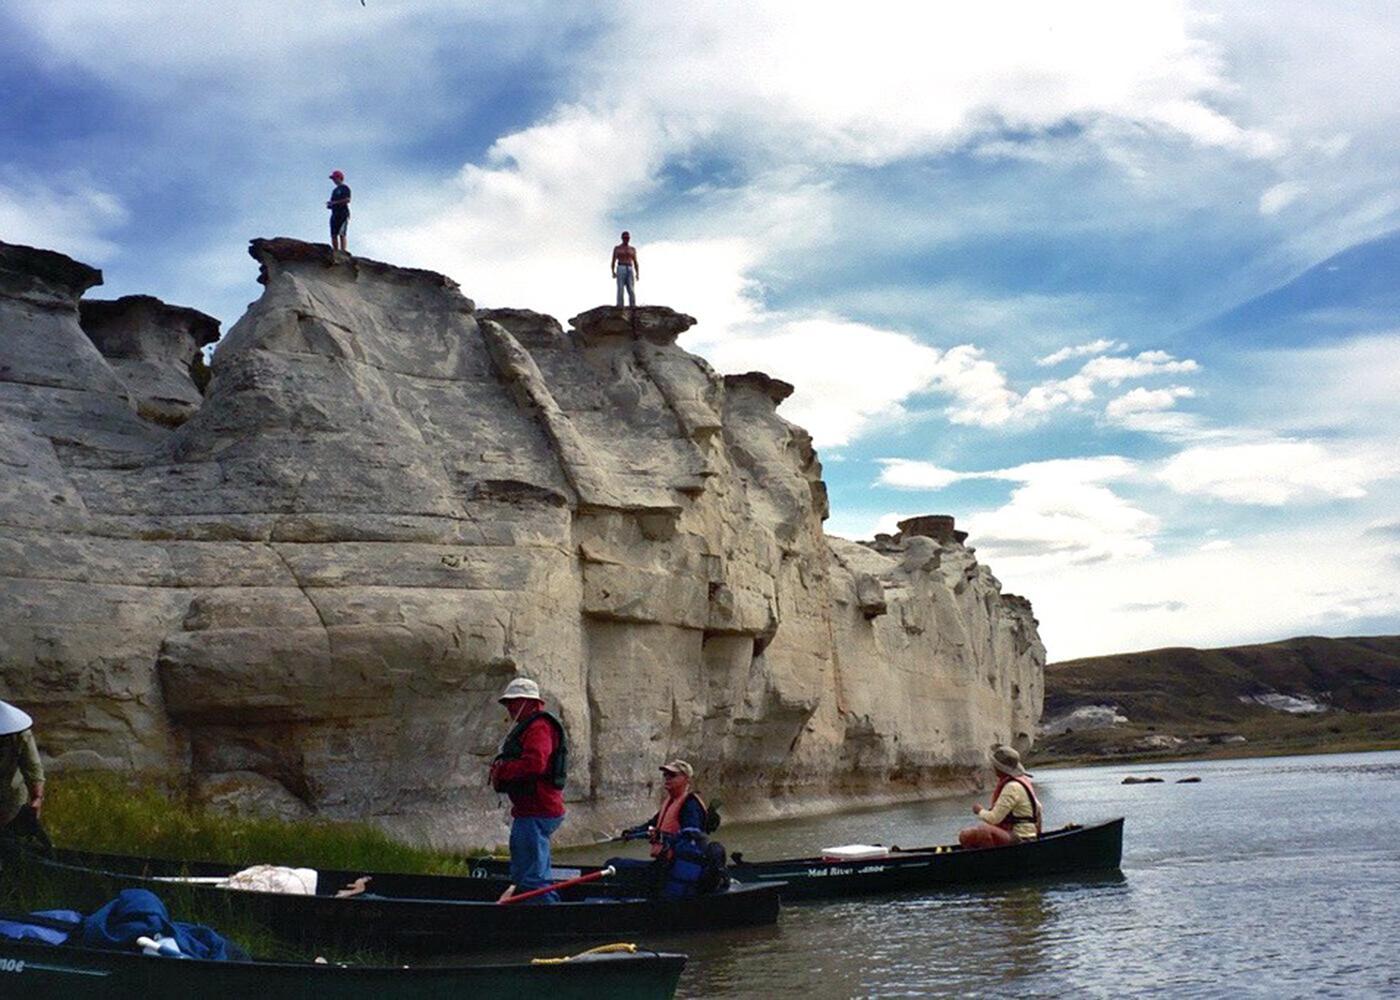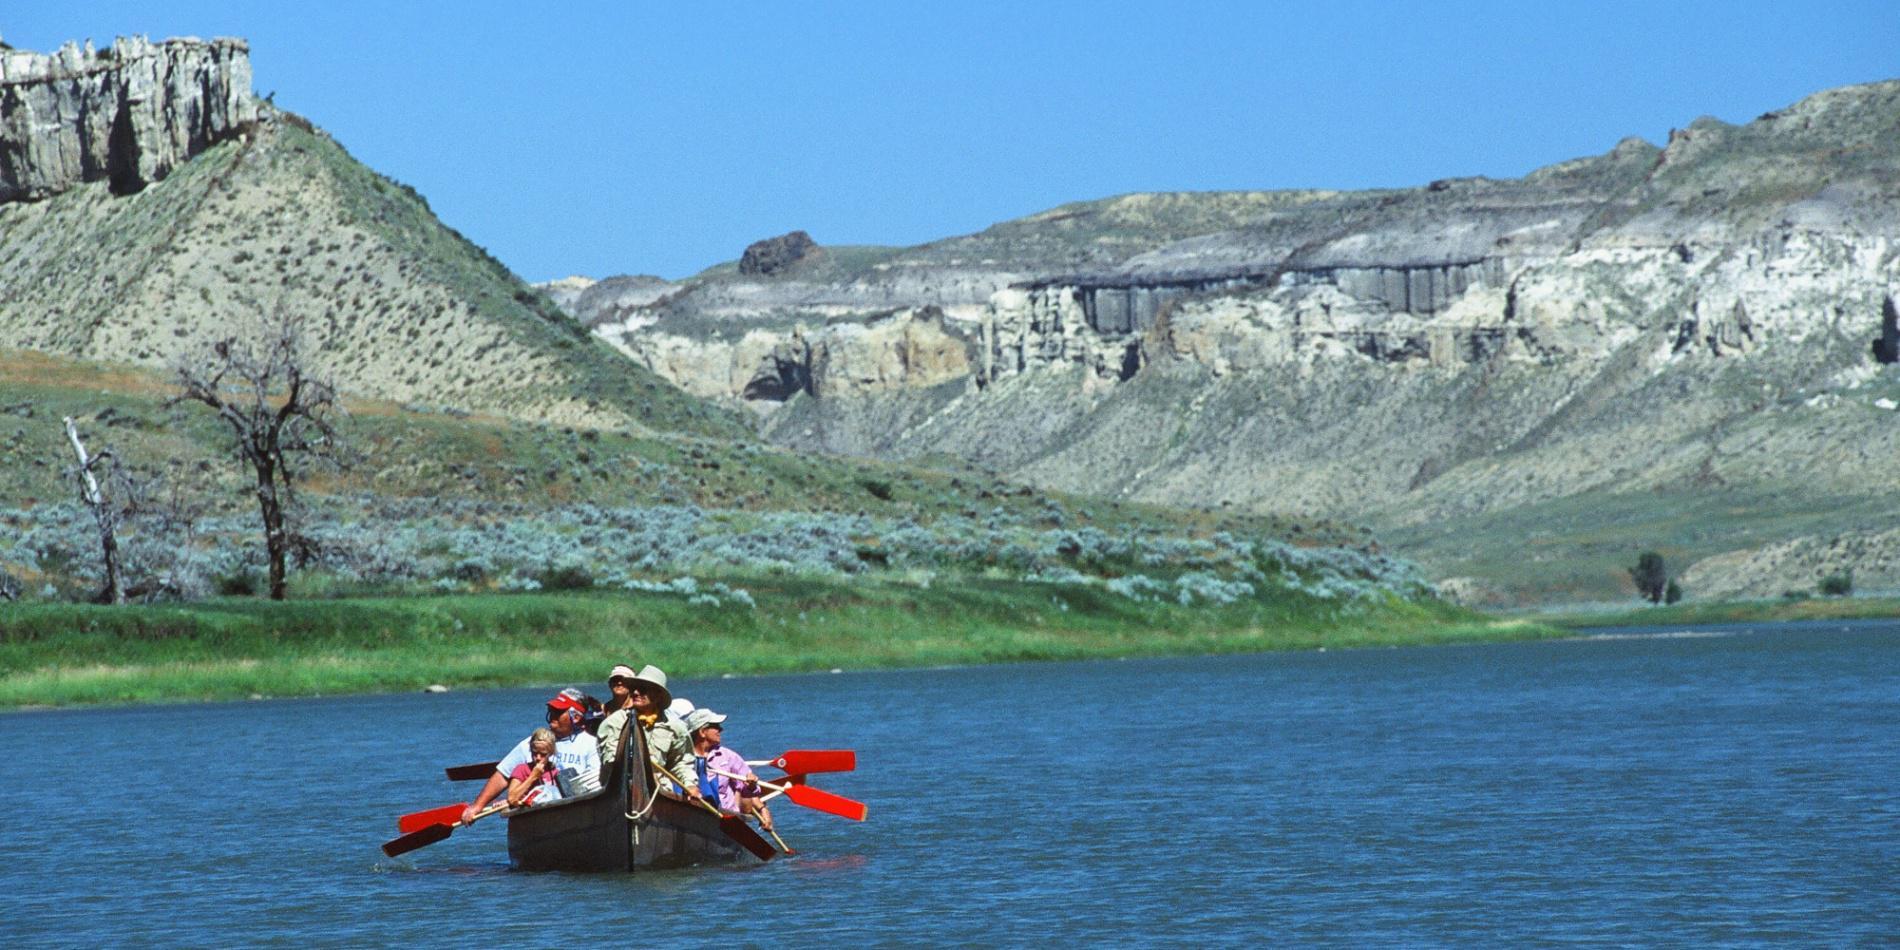The first image is the image on the left, the second image is the image on the right. Evaluate the accuracy of this statement regarding the images: "at least one boat has an oar touching the water surface in the image pair". Is it true? Answer yes or no. No. 